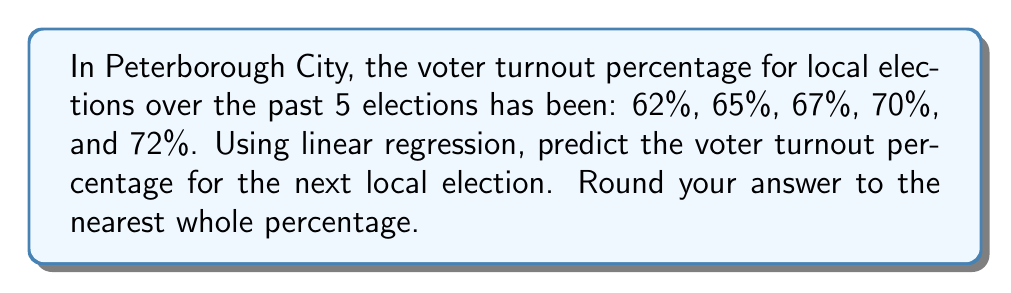Help me with this question. To solve this problem using linear regression, we'll follow these steps:

1. Assign x-values to the elections (1, 2, 3, 4, 5) and y-values to the turnout percentages.
2. Calculate the means of x and y:
   $\bar{x} = \frac{1 + 2 + 3 + 4 + 5}{5} = 3$
   $\bar{y} = \frac{62 + 65 + 67 + 70 + 72}{5} = 67.2$

3. Calculate the slope (m) using the formula:
   $m = \frac{\sum(x_i - \bar{x})(y_i - \bar{y})}{\sum(x_i - \bar{x})^2}$

   $\sum(x_i - \bar{x})(y_i - \bar{y}) = (-2)(-5.2) + (-1)(-2.2) + (0)(-0.2) + (1)(2.8) + (2)(4.8) = 25$
   $\sum(x_i - \bar{x})^2 = (-2)^2 + (-1)^2 + 0^2 + 1^2 + 2^2 = 10$

   $m = \frac{25}{10} = 2.5$

4. Calculate the y-intercept (b) using the formula:
   $b = \bar{y} - m\bar{x} = 67.2 - 2.5(3) = 59.7$

5. The regression line equation is:
   $y = mx + b = 2.5x + 59.7$

6. To predict the next election (x = 6):
   $y = 2.5(6) + 59.7 = 74.7$

7. Rounding to the nearest whole percentage:
   74.7% ≈ 75%
Answer: 75% 